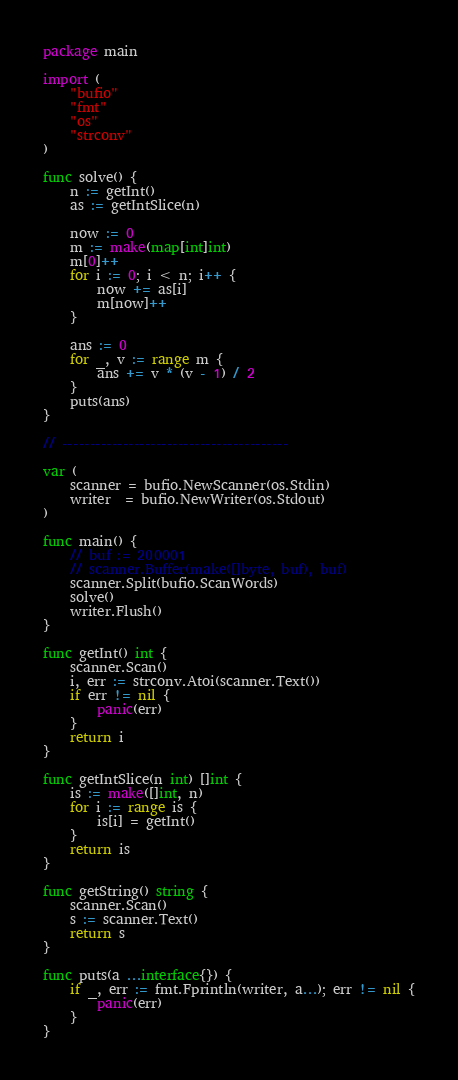Convert code to text. <code><loc_0><loc_0><loc_500><loc_500><_Go_>package main

import (
	"bufio"
	"fmt"
	"os"
	"strconv"
)

func solve() {
	n := getInt()
	as := getIntSlice(n)

	now := 0
	m := make(map[int]int)
	m[0]++
	for i := 0; i < n; i++ {
		now += as[i]
		m[now]++
	}

	ans := 0
	for _, v := range m {
		ans += v * (v - 1) / 2
	}
	puts(ans)
}

// -----------------------------------------

var (
	scanner = bufio.NewScanner(os.Stdin)
	writer  = bufio.NewWriter(os.Stdout)
)

func main() {
	// buf := 200001
	// scanner.Buffer(make([]byte, buf), buf)
	scanner.Split(bufio.ScanWords)
	solve()
	writer.Flush()
}

func getInt() int {
	scanner.Scan()
	i, err := strconv.Atoi(scanner.Text())
	if err != nil {
		panic(err)
	}
	return i
}

func getIntSlice(n int) []int {
	is := make([]int, n)
	for i := range is {
		is[i] = getInt()
	}
	return is
}

func getString() string {
	scanner.Scan()
	s := scanner.Text()
	return s
}

func puts(a ...interface{}) {
	if _, err := fmt.Fprintln(writer, a...); err != nil {
		panic(err)
	}
}
</code> 